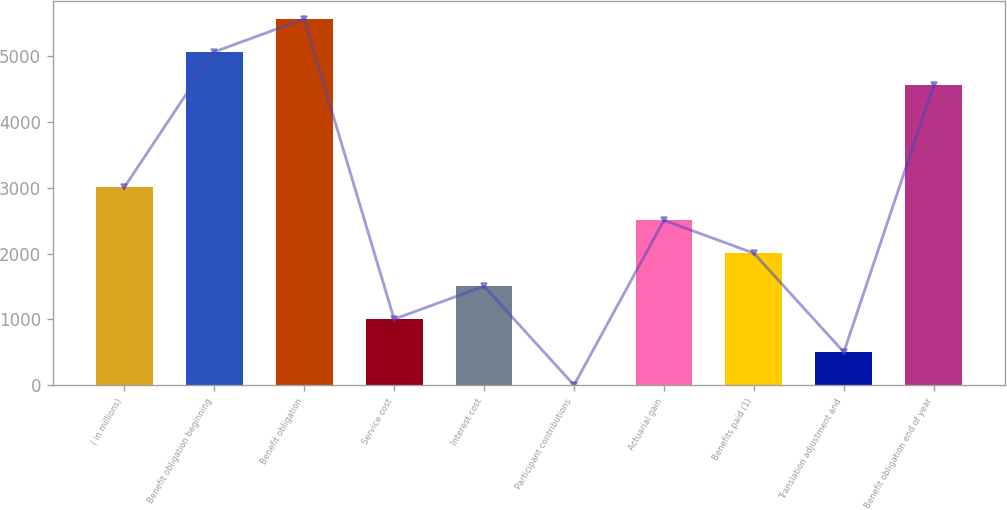<chart> <loc_0><loc_0><loc_500><loc_500><bar_chart><fcel>( in millions)<fcel>Benefit obligation beginning<fcel>Benefit obligation<fcel>Service cost<fcel>Interest cost<fcel>Participant contributions<fcel>Actuarial gain<fcel>Benefits paid (1)<fcel>Translation adjustment and<fcel>Benefit obligation end of year<nl><fcel>3009.4<fcel>5067.4<fcel>5568.8<fcel>1003.8<fcel>1505.2<fcel>1<fcel>2508<fcel>2006.6<fcel>502.4<fcel>4566<nl></chart> 